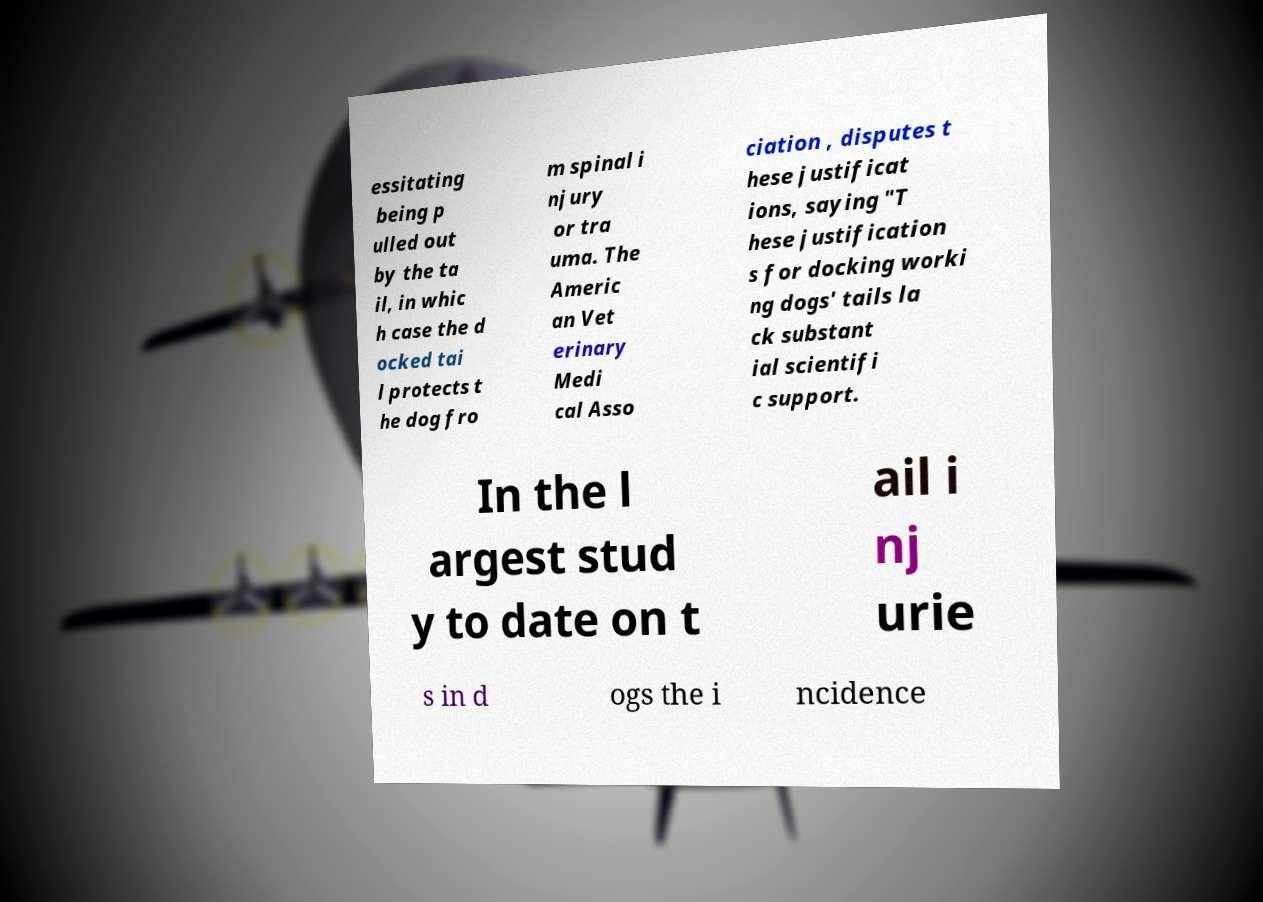What messages or text are displayed in this image? I need them in a readable, typed format. essitating being p ulled out by the ta il, in whic h case the d ocked tai l protects t he dog fro m spinal i njury or tra uma. The Americ an Vet erinary Medi cal Asso ciation , disputes t hese justificat ions, saying "T hese justification s for docking worki ng dogs' tails la ck substant ial scientifi c support. In the l argest stud y to date on t ail i nj urie s in d ogs the i ncidence 